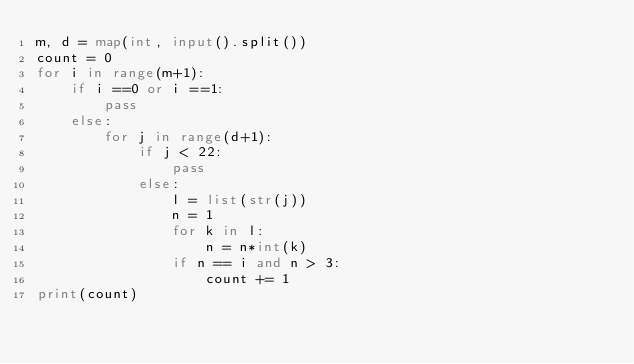Convert code to text. <code><loc_0><loc_0><loc_500><loc_500><_Python_>m, d = map(int, input().split())
count = 0
for i in range(m+1):
    if i ==0 or i ==1:
        pass
    else:
        for j in range(d+1):
            if j < 22:
                pass
            else:
                l = list(str(j))
                n = 1
                for k in l:
                    n = n*int(k)
                if n == i and n > 3:
                    count += 1
print(count)</code> 